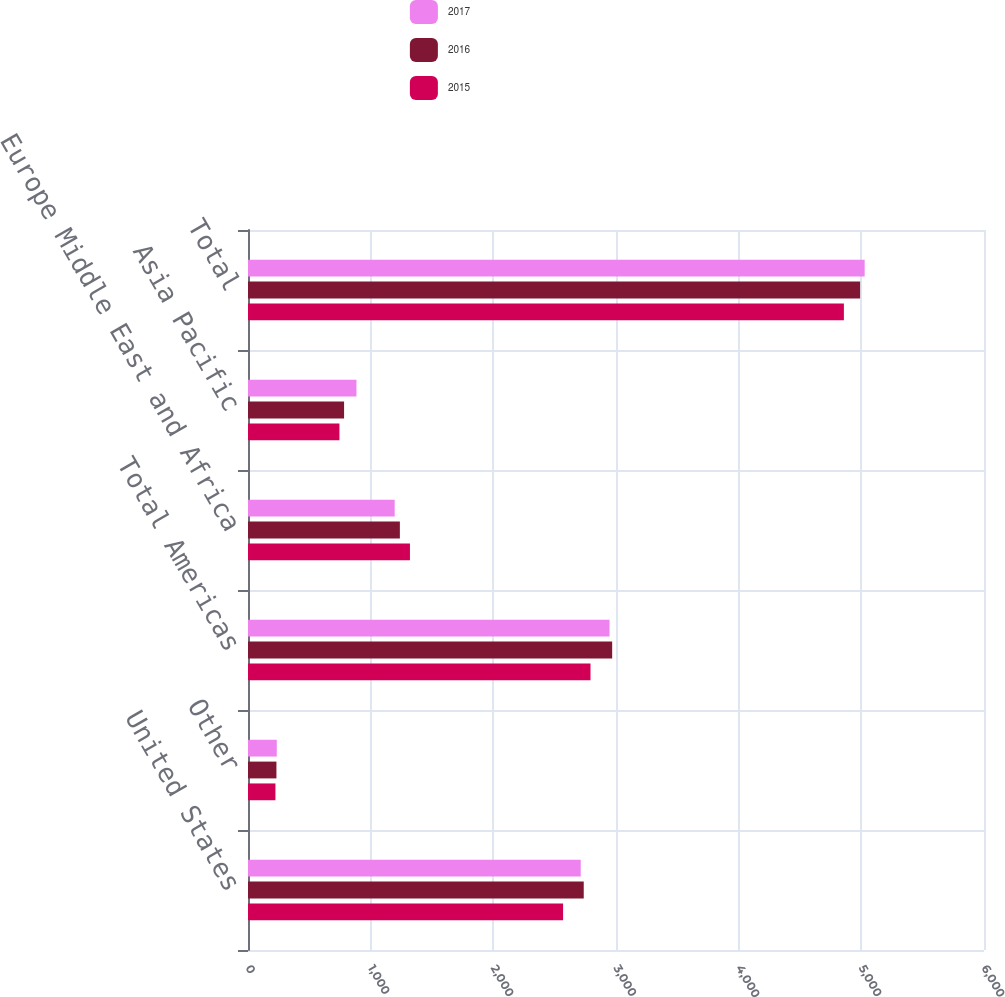<chart> <loc_0><loc_0><loc_500><loc_500><stacked_bar_chart><ecel><fcel>United States<fcel>Other<fcel>Total Americas<fcel>Europe Middle East and Africa<fcel>Asia Pacific<fcel>Total<nl><fcel>2017<fcel>2712.6<fcel>234.6<fcel>2947.2<fcel>1195.8<fcel>884.2<fcel>5027.2<nl><fcel>2016<fcel>2737<fcel>231.8<fcel>2968.8<fcel>1238.1<fcel>783.2<fcel>4990.1<nl><fcel>2015<fcel>2568.6<fcel>223.6<fcel>2792.2<fcel>1320.3<fcel>745.3<fcel>4857.8<nl></chart> 